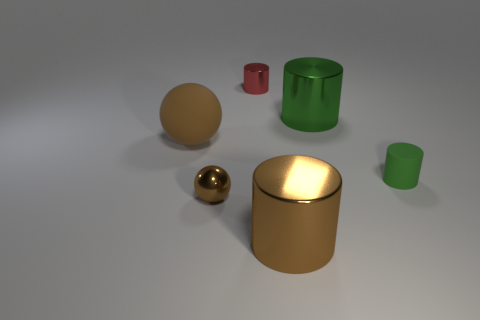Subtract all brown shiny cylinders. How many cylinders are left? 3 Subtract 1 cylinders. How many cylinders are left? 3 Subtract all red cylinders. How many cylinders are left? 3 Subtract all gray cylinders. Subtract all cyan spheres. How many cylinders are left? 4 Add 1 large brown objects. How many objects exist? 7 Subtract all cylinders. How many objects are left? 2 Subtract 0 green balls. How many objects are left? 6 Subtract all large blue shiny cylinders. Subtract all metal objects. How many objects are left? 2 Add 4 green metallic things. How many green metallic things are left? 5 Add 2 brown metallic cylinders. How many brown metallic cylinders exist? 3 